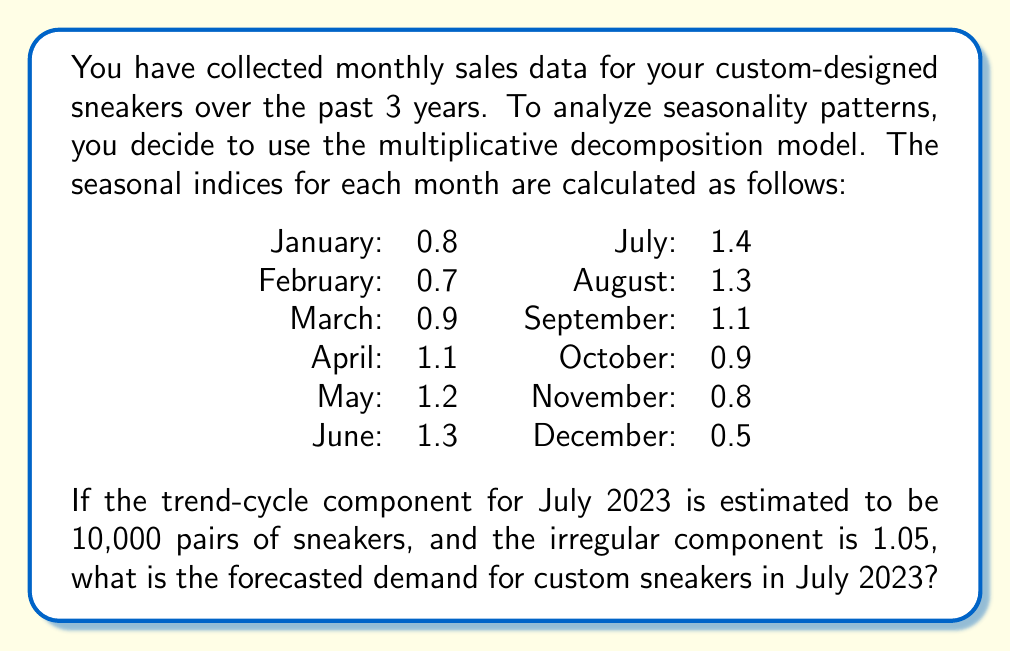Can you answer this question? To solve this problem, we need to use the multiplicative decomposition model for time series analysis. The model is represented as:

$$ Y_t = T_t \times S_t \times I_t $$

Where:
$Y_t$ is the observed value (forecast)
$T_t$ is the trend-cycle component
$S_t$ is the seasonal component
$I_t$ is the irregular component

We are given the following information:
1. Trend-cycle component ($T_t$) for July 2023 = 10,000 pairs
2. Seasonal index ($S_t$) for July = 1.4
3. Irregular component ($I_t$) = 1.05

To calculate the forecasted demand, we simply multiply these components:

$$ Y_t = 10,000 \times 1.4 \times 1.05 $$

$$ Y_t = 14,700 \text{ pairs of sneakers} $$

This result indicates that the forecasted demand for custom sneakers in July 2023 is 14,700 pairs, taking into account the trend-cycle, seasonality, and irregular factors.
Answer: 14,700 pairs of sneakers 